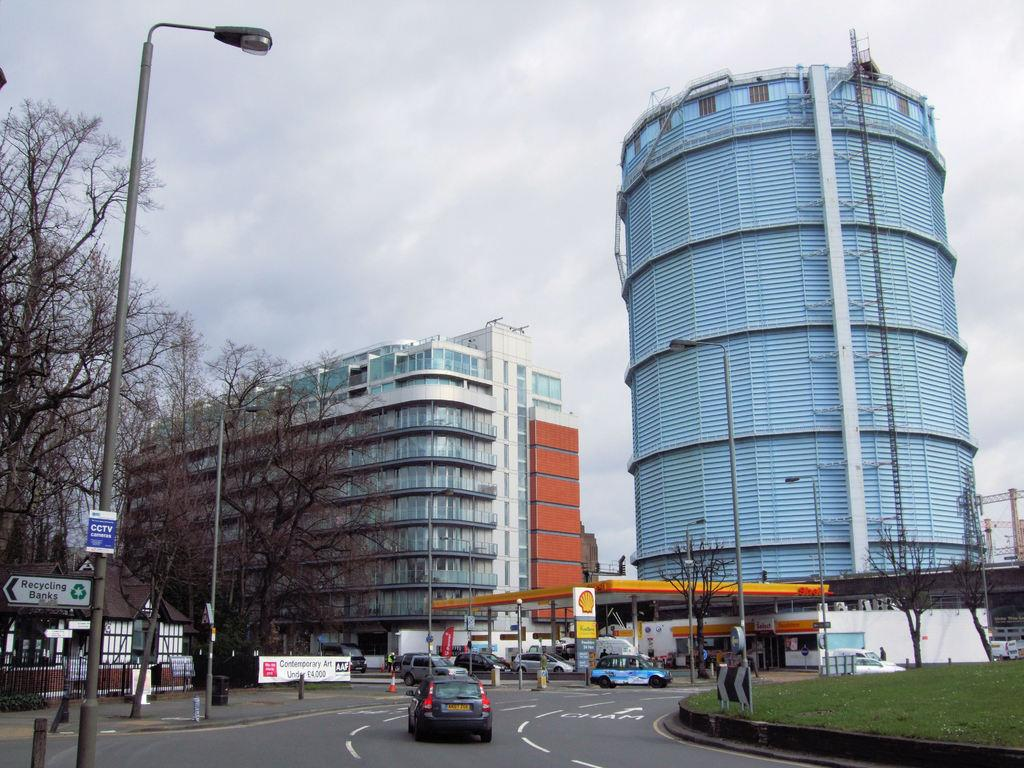What can be seen in the sky in the image? The sky with clouds is visible in the image. What type of structures are present in the image? There are buildings in the image. What objects are used for storage or transportation in the image? Containers and motor vehicles are present in the image. What is used for climbing in the image? A ladder is visible in the image. What type of infrastructure is present in the image? Pipelines are in the image. What type of vegetation is present in the image? Trees are present in the image. What type of street furniture is visible in the image? Street poles and street lights are visible in the image. What type of waste disposal units are present in the image? Bins are present in the image. What type of chicken is being bitten by a dog in the image? There is no chicken or dog present in the image. What type of experience can be gained from the image? The image does not depict an experience; it is a static representation of various elements in a scene. 